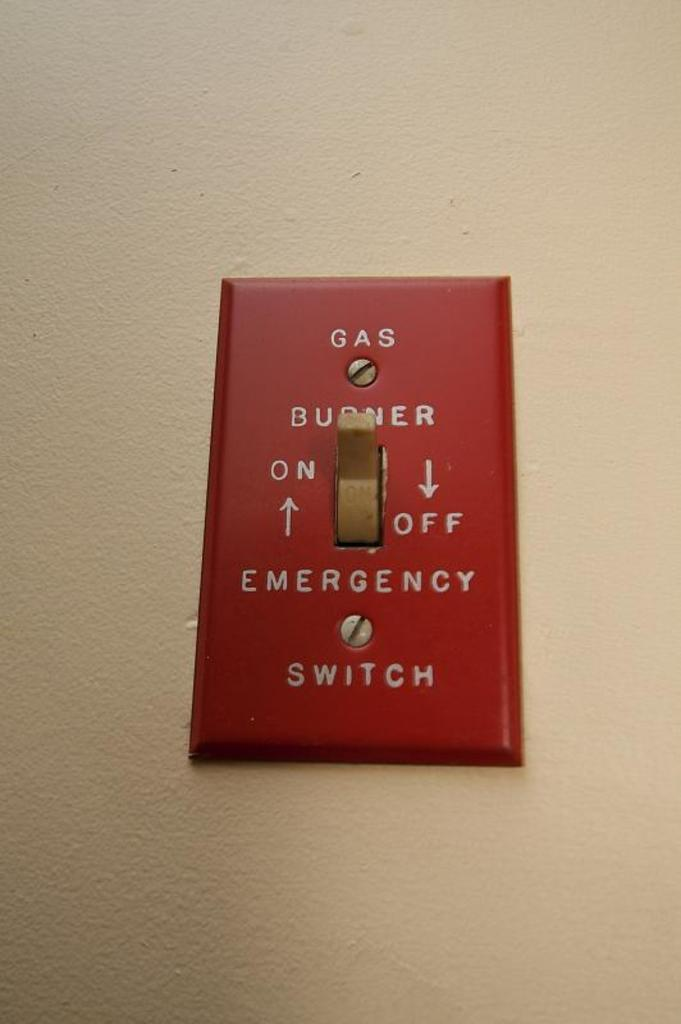<image>
Give a short and clear explanation of the subsequent image. An emergency on-off switch for a gas burner currently set to the on position. 